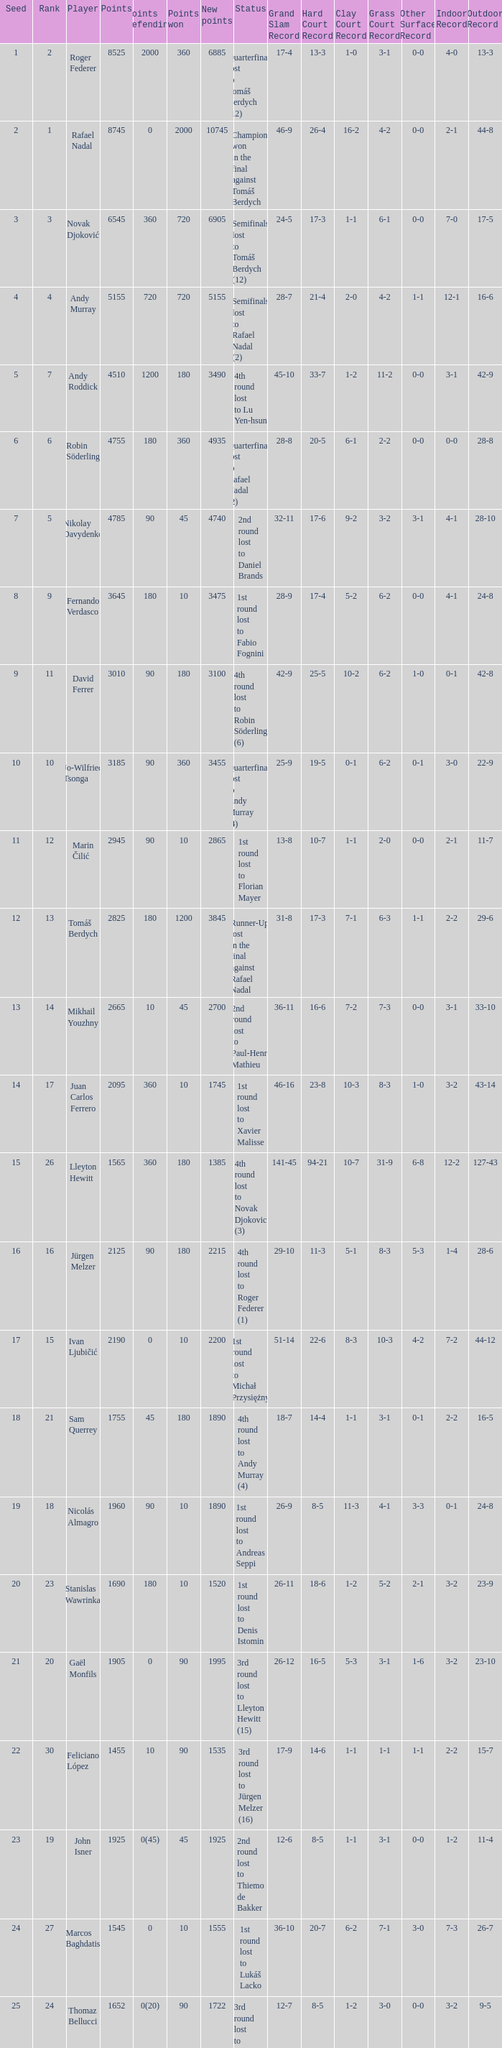Identify the total points that require defense for achieving 1075. 1.0. 